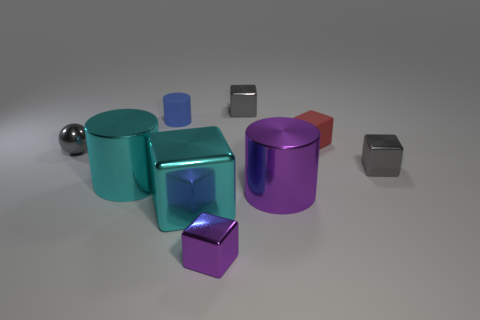There is a gray cube that is left of the rubber block; is it the same size as the tiny gray sphere?
Ensure brevity in your answer.  Yes. Is the number of tiny shiny cubes that are behind the cyan cylinder greater than the number of big blocks?
Keep it short and to the point. Yes. Do the red object and the tiny purple shiny object have the same shape?
Give a very brief answer. Yes. The cyan cube has what size?
Make the answer very short. Large. Are there more small metal things behind the cyan cube than blue rubber objects in front of the small gray shiny ball?
Make the answer very short. Yes. Are there any red objects left of the tiny cylinder?
Provide a short and direct response. No. Are there any gray cubes of the same size as the red rubber cube?
Offer a terse response. Yes. There is a tiny ball that is made of the same material as the large purple object; what color is it?
Your response must be concise. Gray. What is the tiny blue cylinder made of?
Your answer should be very brief. Rubber. What shape is the blue thing?
Provide a succinct answer. Cylinder. 